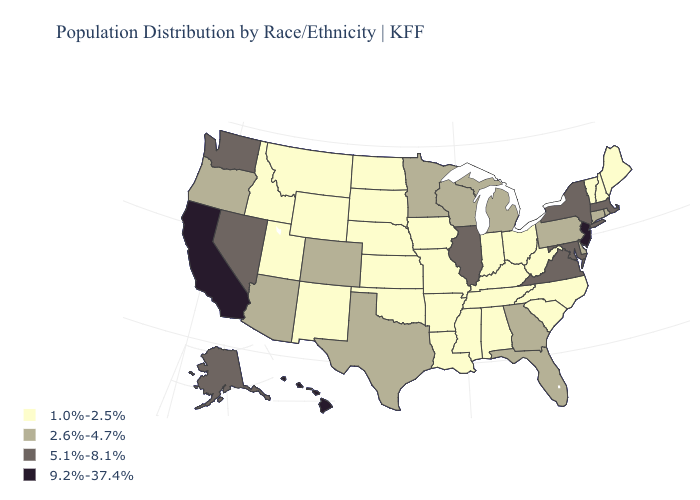Does Wyoming have a lower value than Florida?
Answer briefly. Yes. Name the states that have a value in the range 9.2%-37.4%?
Answer briefly. California, Hawaii, New Jersey. Does Nevada have the lowest value in the West?
Answer briefly. No. Name the states that have a value in the range 5.1%-8.1%?
Quick response, please. Alaska, Illinois, Maryland, Massachusetts, Nevada, New York, Virginia, Washington. Which states hav the highest value in the Northeast?
Quick response, please. New Jersey. What is the lowest value in the West?
Keep it brief. 1.0%-2.5%. What is the lowest value in the Northeast?
Quick response, please. 1.0%-2.5%. Does the first symbol in the legend represent the smallest category?
Keep it brief. Yes. Name the states that have a value in the range 1.0%-2.5%?
Be succinct. Alabama, Arkansas, Idaho, Indiana, Iowa, Kansas, Kentucky, Louisiana, Maine, Mississippi, Missouri, Montana, Nebraska, New Hampshire, New Mexico, North Carolina, North Dakota, Ohio, Oklahoma, South Carolina, South Dakota, Tennessee, Utah, Vermont, West Virginia, Wyoming. Does Oklahoma have the same value as Oregon?
Keep it brief. No. Name the states that have a value in the range 2.6%-4.7%?
Keep it brief. Arizona, Colorado, Connecticut, Delaware, Florida, Georgia, Michigan, Minnesota, Oregon, Pennsylvania, Rhode Island, Texas, Wisconsin. What is the value of Texas?
Quick response, please. 2.6%-4.7%. Name the states that have a value in the range 1.0%-2.5%?
Keep it brief. Alabama, Arkansas, Idaho, Indiana, Iowa, Kansas, Kentucky, Louisiana, Maine, Mississippi, Missouri, Montana, Nebraska, New Hampshire, New Mexico, North Carolina, North Dakota, Ohio, Oklahoma, South Carolina, South Dakota, Tennessee, Utah, Vermont, West Virginia, Wyoming. What is the value of South Carolina?
Give a very brief answer. 1.0%-2.5%. Name the states that have a value in the range 9.2%-37.4%?
Quick response, please. California, Hawaii, New Jersey. 